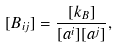<formula> <loc_0><loc_0><loc_500><loc_500>[ B _ { i j } ] = \frac { [ k _ { B } ] } { [ a ^ { i } ] [ a ^ { j } ] } ,</formula> 